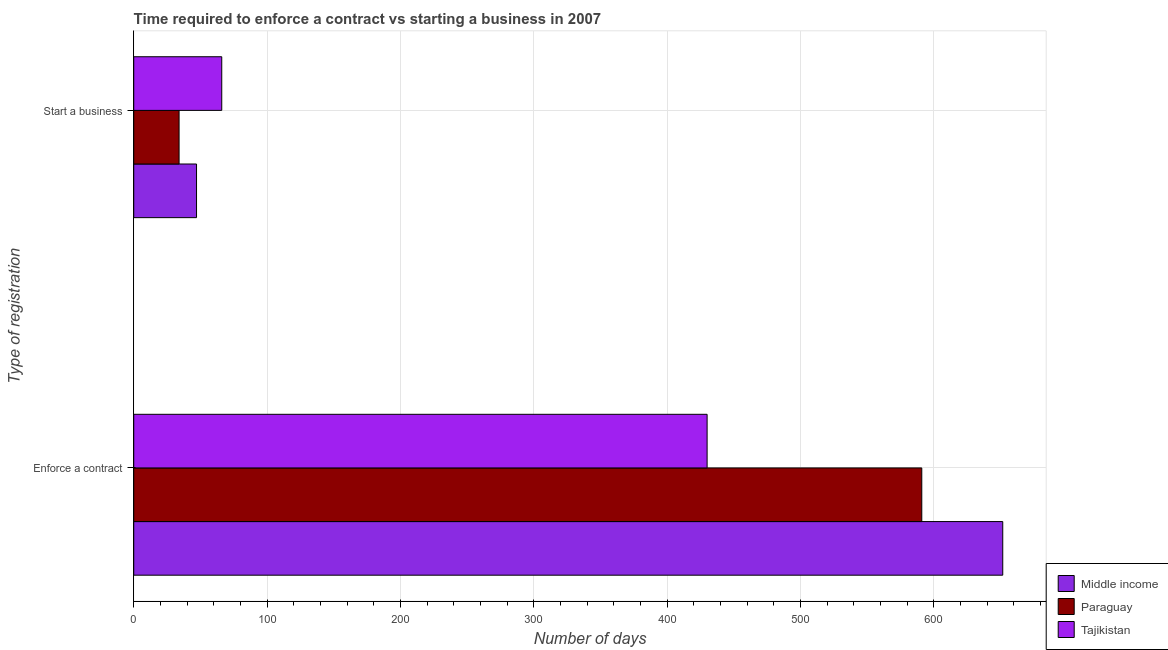How many different coloured bars are there?
Ensure brevity in your answer.  3. Are the number of bars per tick equal to the number of legend labels?
Your answer should be compact. Yes. What is the label of the 2nd group of bars from the top?
Offer a very short reply. Enforce a contract. What is the number of days to enforece a contract in Paraguay?
Ensure brevity in your answer.  591. Across all countries, what is the minimum number of days to enforece a contract?
Provide a succinct answer. 430. In which country was the number of days to enforece a contract minimum?
Keep it short and to the point. Tajikistan. What is the total number of days to enforece a contract in the graph?
Keep it short and to the point. 1672.72. What is the difference between the number of days to enforece a contract in Middle income and that in Tajikistan?
Provide a succinct answer. 221.72. What is the difference between the number of days to start a business in Paraguay and the number of days to enforece a contract in Middle income?
Give a very brief answer. -617.72. What is the average number of days to start a business per country?
Provide a succinct answer. 49.03. What is the difference between the number of days to start a business and number of days to enforece a contract in Tajikistan?
Keep it short and to the point. -364. In how many countries, is the number of days to enforece a contract greater than 400 days?
Give a very brief answer. 3. What is the ratio of the number of days to enforece a contract in Middle income to that in Tajikistan?
Provide a short and direct response. 1.52. What does the 2nd bar from the top in Start a business represents?
Provide a succinct answer. Paraguay. What does the 3rd bar from the bottom in Enforce a contract represents?
Provide a short and direct response. Tajikistan. Are all the bars in the graph horizontal?
Ensure brevity in your answer.  Yes. Where does the legend appear in the graph?
Your answer should be very brief. Bottom right. What is the title of the graph?
Ensure brevity in your answer.  Time required to enforce a contract vs starting a business in 2007. Does "Timor-Leste" appear as one of the legend labels in the graph?
Provide a short and direct response. No. What is the label or title of the X-axis?
Your response must be concise. Number of days. What is the label or title of the Y-axis?
Keep it short and to the point. Type of registration. What is the Number of days in Middle income in Enforce a contract?
Offer a very short reply. 651.72. What is the Number of days in Paraguay in Enforce a contract?
Keep it short and to the point. 591. What is the Number of days of Tajikistan in Enforce a contract?
Provide a succinct answer. 430. What is the Number of days in Middle income in Start a business?
Your response must be concise. 47.1. What is the Number of days of Paraguay in Start a business?
Offer a very short reply. 34. Across all Type of registration, what is the maximum Number of days of Middle income?
Your response must be concise. 651.72. Across all Type of registration, what is the maximum Number of days in Paraguay?
Ensure brevity in your answer.  591. Across all Type of registration, what is the maximum Number of days in Tajikistan?
Provide a succinct answer. 430. Across all Type of registration, what is the minimum Number of days of Middle income?
Ensure brevity in your answer.  47.1. What is the total Number of days of Middle income in the graph?
Keep it short and to the point. 698.81. What is the total Number of days of Paraguay in the graph?
Offer a terse response. 625. What is the total Number of days of Tajikistan in the graph?
Keep it short and to the point. 496. What is the difference between the Number of days in Middle income in Enforce a contract and that in Start a business?
Offer a very short reply. 604.62. What is the difference between the Number of days in Paraguay in Enforce a contract and that in Start a business?
Your answer should be compact. 557. What is the difference between the Number of days of Tajikistan in Enforce a contract and that in Start a business?
Provide a succinct answer. 364. What is the difference between the Number of days in Middle income in Enforce a contract and the Number of days in Paraguay in Start a business?
Your response must be concise. 617.72. What is the difference between the Number of days in Middle income in Enforce a contract and the Number of days in Tajikistan in Start a business?
Give a very brief answer. 585.72. What is the difference between the Number of days in Paraguay in Enforce a contract and the Number of days in Tajikistan in Start a business?
Give a very brief answer. 525. What is the average Number of days in Middle income per Type of registration?
Ensure brevity in your answer.  349.41. What is the average Number of days of Paraguay per Type of registration?
Ensure brevity in your answer.  312.5. What is the average Number of days in Tajikistan per Type of registration?
Make the answer very short. 248. What is the difference between the Number of days of Middle income and Number of days of Paraguay in Enforce a contract?
Ensure brevity in your answer.  60.72. What is the difference between the Number of days of Middle income and Number of days of Tajikistan in Enforce a contract?
Offer a very short reply. 221.72. What is the difference between the Number of days of Paraguay and Number of days of Tajikistan in Enforce a contract?
Make the answer very short. 161. What is the difference between the Number of days of Middle income and Number of days of Paraguay in Start a business?
Keep it short and to the point. 13.1. What is the difference between the Number of days in Middle income and Number of days in Tajikistan in Start a business?
Keep it short and to the point. -18.9. What is the difference between the Number of days of Paraguay and Number of days of Tajikistan in Start a business?
Offer a terse response. -32. What is the ratio of the Number of days of Middle income in Enforce a contract to that in Start a business?
Give a very brief answer. 13.84. What is the ratio of the Number of days of Paraguay in Enforce a contract to that in Start a business?
Your answer should be very brief. 17.38. What is the ratio of the Number of days in Tajikistan in Enforce a contract to that in Start a business?
Your response must be concise. 6.52. What is the difference between the highest and the second highest Number of days in Middle income?
Your answer should be very brief. 604.62. What is the difference between the highest and the second highest Number of days of Paraguay?
Make the answer very short. 557. What is the difference between the highest and the second highest Number of days in Tajikistan?
Provide a short and direct response. 364. What is the difference between the highest and the lowest Number of days of Middle income?
Offer a very short reply. 604.62. What is the difference between the highest and the lowest Number of days of Paraguay?
Ensure brevity in your answer.  557. What is the difference between the highest and the lowest Number of days in Tajikistan?
Keep it short and to the point. 364. 